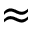Convert formula to latex. <formula><loc_0><loc_0><loc_500><loc_500>\approx</formula> 